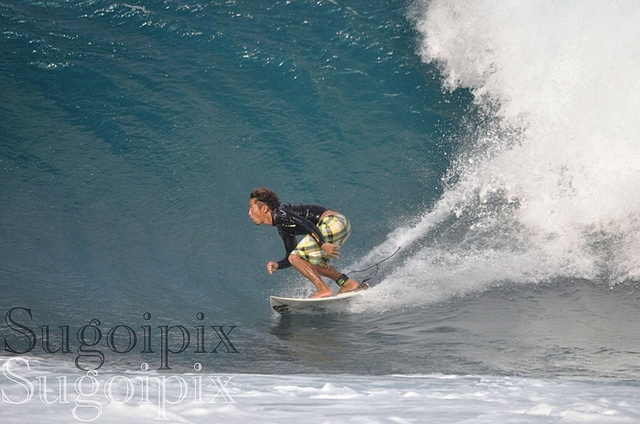Describe the objects in this image and their specific colors. I can see people in darkblue, black, gray, and tan tones and surfboard in darkblue, gray, ivory, darkgray, and black tones in this image. 